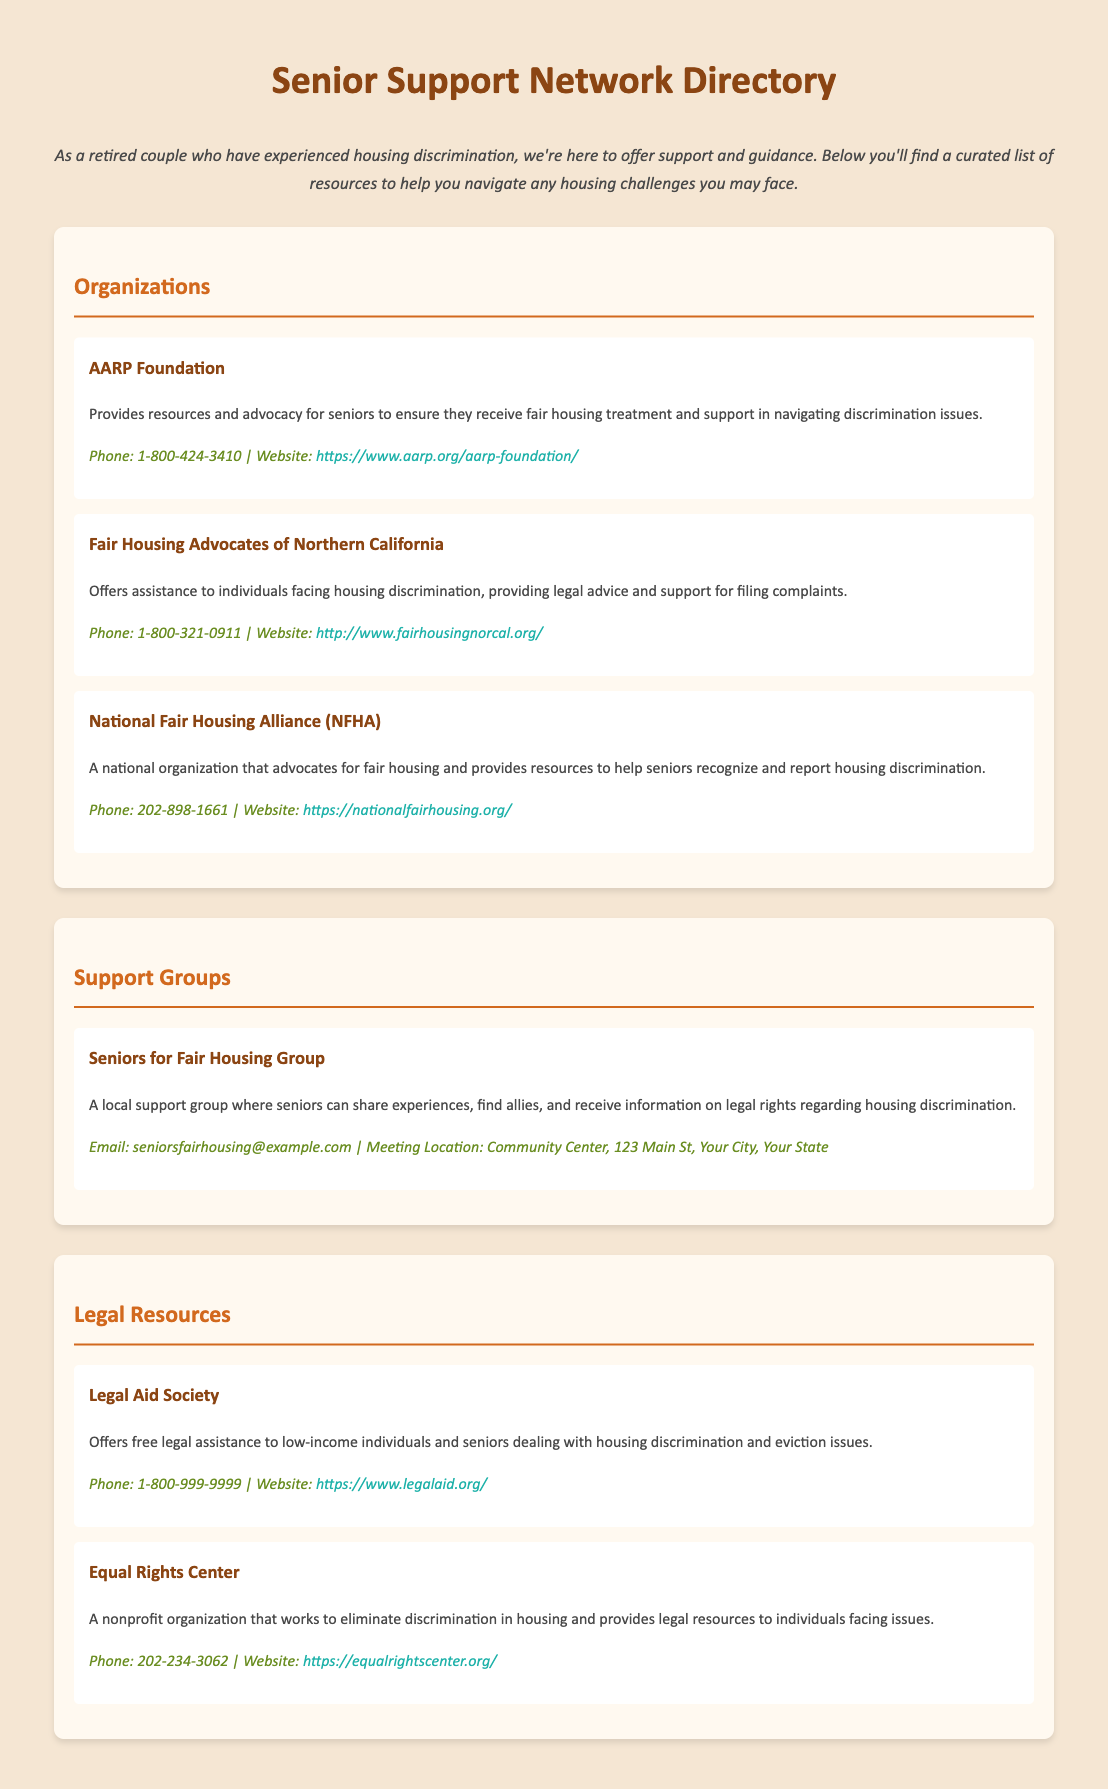What is the title of the directory? The title of the directory is prominently displayed in the header of the document.
Answer: Senior Support Network Directory What is the contact phone number for AARP Foundation? The document provides specific contact information for AARP Foundation under their description.
Answer: 1-800-424-3410 Who does the Legal Aid Society assist? The information regarding Legal Aid Society in the document specifies the target group they assist.
Answer: low-income individuals and seniors What is the location for Seniors for Fair Housing Group meetings? The contact information for the support group includes the meeting location listed in the document.
Answer: Community Center, 123 Main St, Your City, Your State How many organizations are listed in the catalog? The number of organizations is derived from counting the organization sections under the 'Organizations' header.
Answer: 3 What is the purpose of the Equal Rights Center? The document describes the function and focus of the Equal Rights Center as stated within it.
Answer: eliminate discrimination in housing What type of assistance does the Fair Housing Advocates of Northern California provide? The document details what support is offered by the organization mentioned.
Answer: legal advice and support What is the email address for Seniors for Fair Housing Group? The contact information for the support group includes a provided email address in the document.
Answer: seniorsfairhousing@example.com 